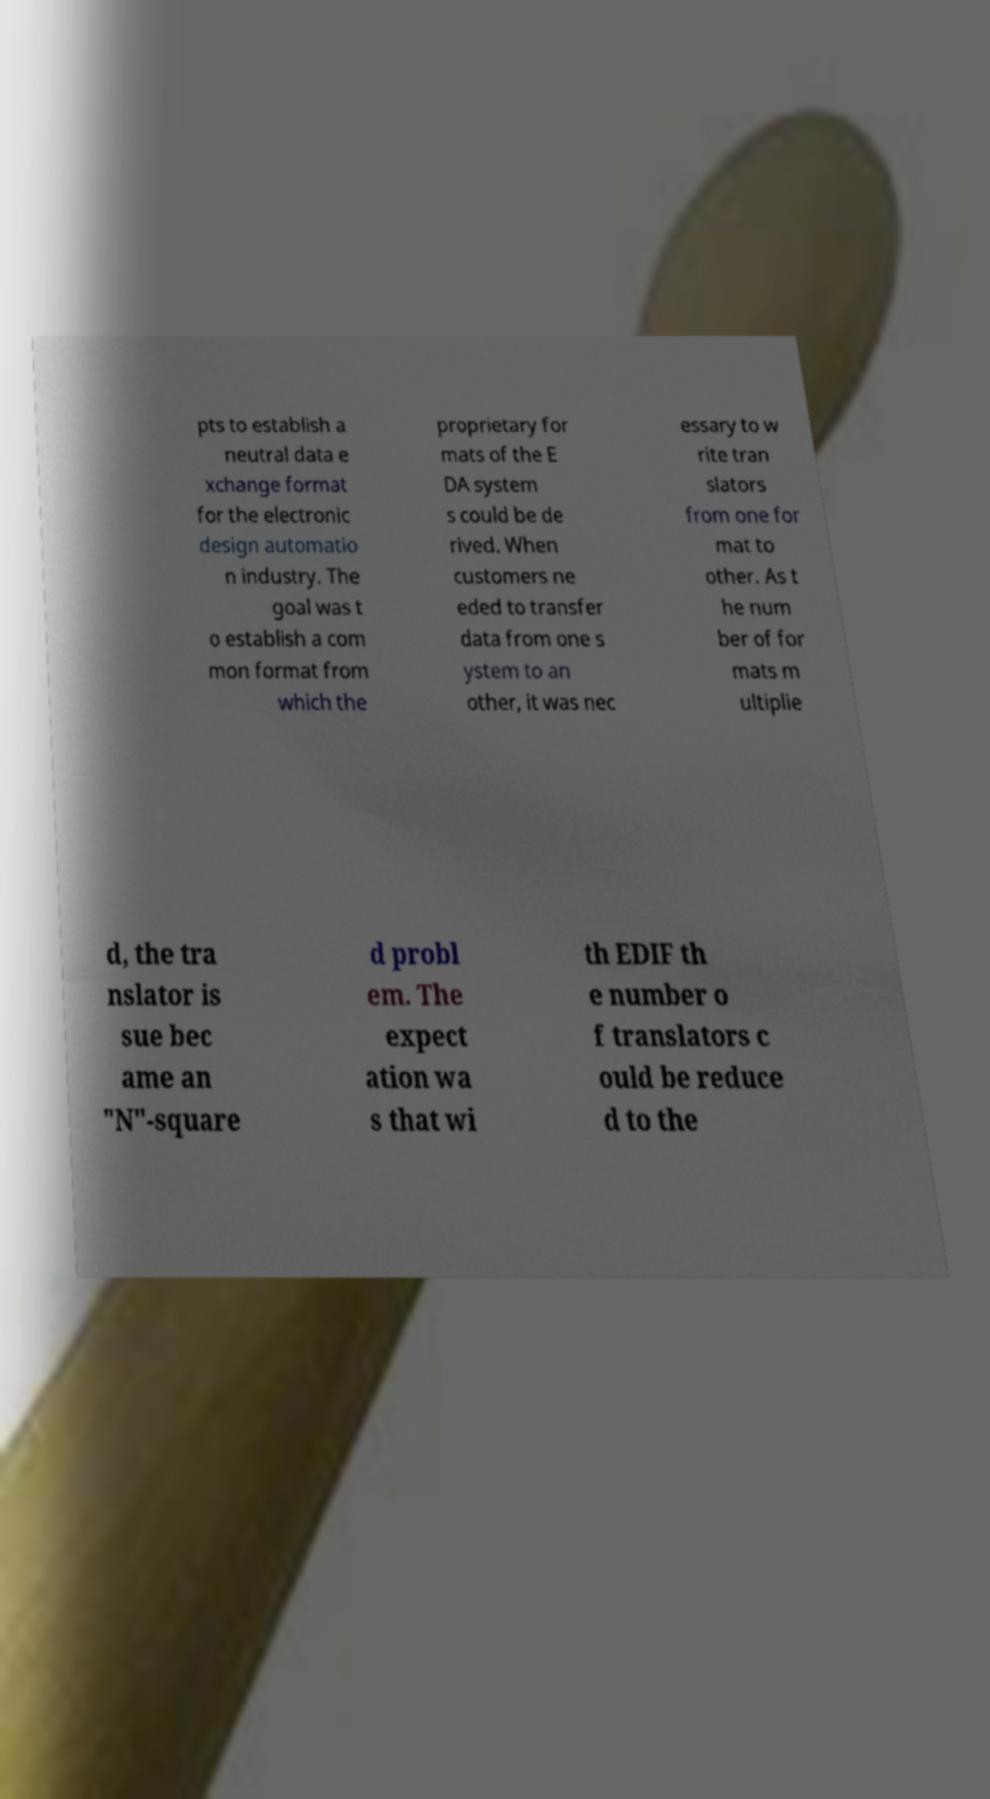Please read and relay the text visible in this image. What does it say? pts to establish a neutral data e xchange format for the electronic design automatio n industry. The goal was t o establish a com mon format from which the proprietary for mats of the E DA system s could be de rived. When customers ne eded to transfer data from one s ystem to an other, it was nec essary to w rite tran slators from one for mat to other. As t he num ber of for mats m ultiplie d, the tra nslator is sue bec ame an "N"-square d probl em. The expect ation wa s that wi th EDIF th e number o f translators c ould be reduce d to the 